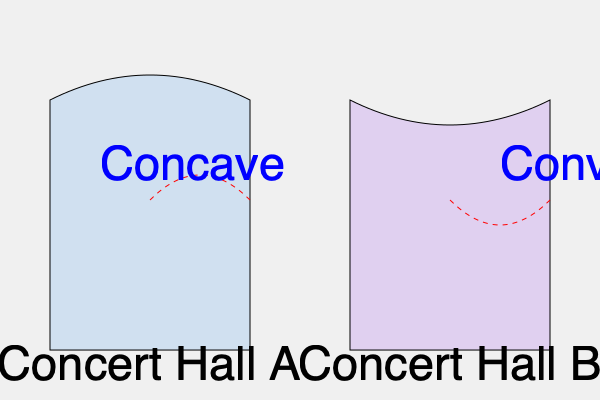Compare the acoustic properties of Concert Hall A and Concert Hall B based on their cross-sectional shapes. Which hall is more likely to produce focused sound reflections, and how might this affect the listening experience for the audience? To answer this question, we need to analyze the cross-sectional shapes of both concert halls and understand how they affect sound reflection:

1. Concert Hall A:
   - Has a concave ceiling shape
   - Sound waves from the stage will tend to converge after reflection
   - This creates focused sound reflections

2. Concert Hall B:
   - Has a convex ceiling shape
   - Sound waves from the stage will tend to diverge after reflection
   - This creates diffuse sound reflections

3. Effect on sound focusing:
   - Concert Hall A is more likely to produce focused sound reflections due to its concave shape
   - Focused reflections can create "hot spots" where sound intensity is higher

4. Impact on listening experience:
   - In Concert Hall A:
     - Some areas may experience increased sound intensity
     - Potential for echoes or sound distortion in certain seats
     - Uneven sound distribution across the audience
   
   - In Concert Hall B:
     - More even sound distribution
     - Reduced risk of echoes or distortion
     - Generally more balanced acoustic experience

5. Acoustic considerations:
   - Focused reflections can enhance loudness and intimacy in smaller venues
   - Diffuse reflections are often preferred in larger concert halls for more uniform sound

6. Historical context:
   - Many famous concert halls (e.g., Boston Symphony Hall) use a combination of shapes to balance focus and diffusion
   - Modern acoustic design often aims for a balance between reflection and diffusion

In conclusion, Concert Hall A is more likely to produce focused sound reflections, which can lead to a more intense but potentially uneven listening experience, while Concert Hall B offers a more balanced acoustic environment.
Answer: Concert Hall A; focused reflections create intense but potentially uneven sound distribution. 